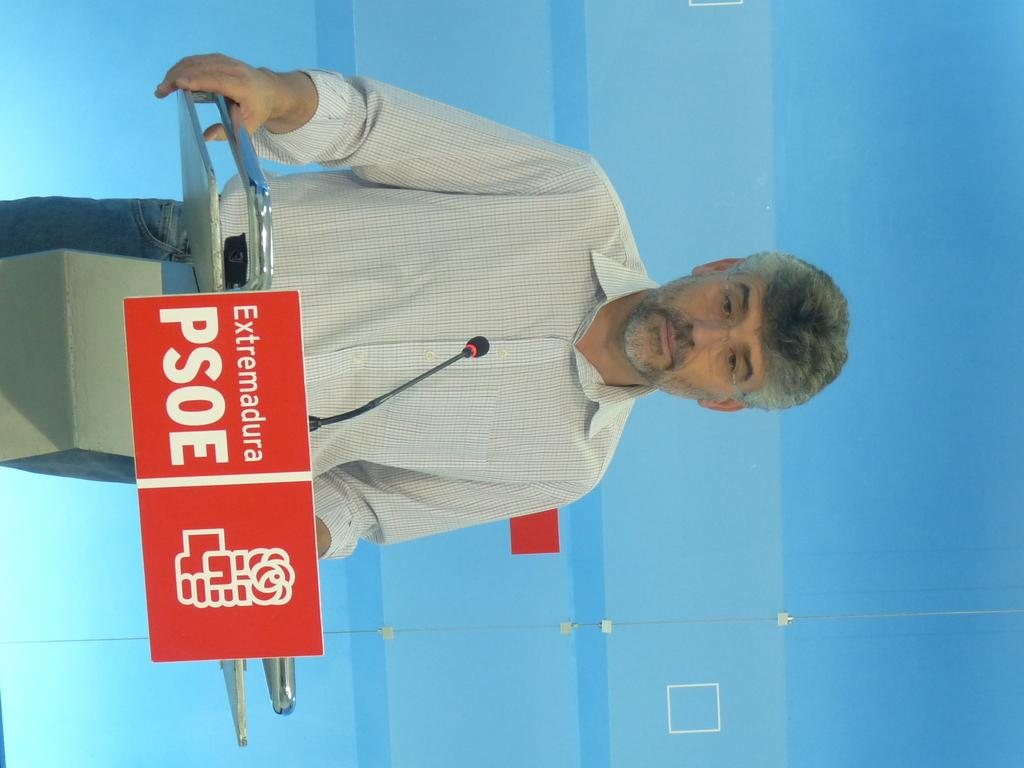Who or what is in the image? There is a person in the image. What object is in front of the person? There is a podium in the image. What is on the podium? A microphone is present on the podium. What color is the background of the image? The background of the image is blue in color. What type of muscle is being flexed by the person in the image? There is no indication of the person flexing any muscles in the image. 